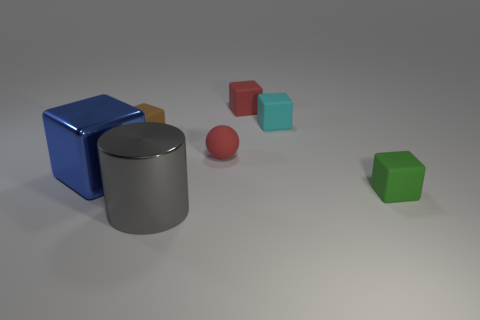What time of day or lighting conditions does the setting suggest? The setting in the image suggests an indoor environment with artificial lighting. The shadows of the objects are soft and diffused, indicating a light source above that is casting an even, non-directional light, commonly found in indoor photography studios or with controlled lighting setups. 